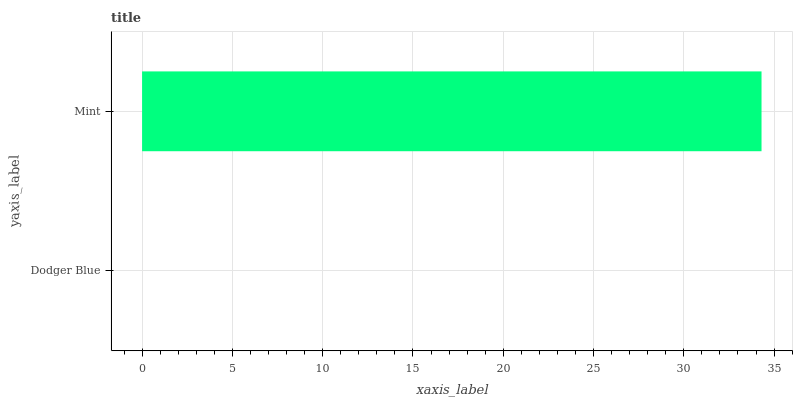Is Dodger Blue the minimum?
Answer yes or no. Yes. Is Mint the maximum?
Answer yes or no. Yes. Is Mint the minimum?
Answer yes or no. No. Is Mint greater than Dodger Blue?
Answer yes or no. Yes. Is Dodger Blue less than Mint?
Answer yes or no. Yes. Is Dodger Blue greater than Mint?
Answer yes or no. No. Is Mint less than Dodger Blue?
Answer yes or no. No. Is Mint the high median?
Answer yes or no. Yes. Is Dodger Blue the low median?
Answer yes or no. Yes. Is Dodger Blue the high median?
Answer yes or no. No. Is Mint the low median?
Answer yes or no. No. 